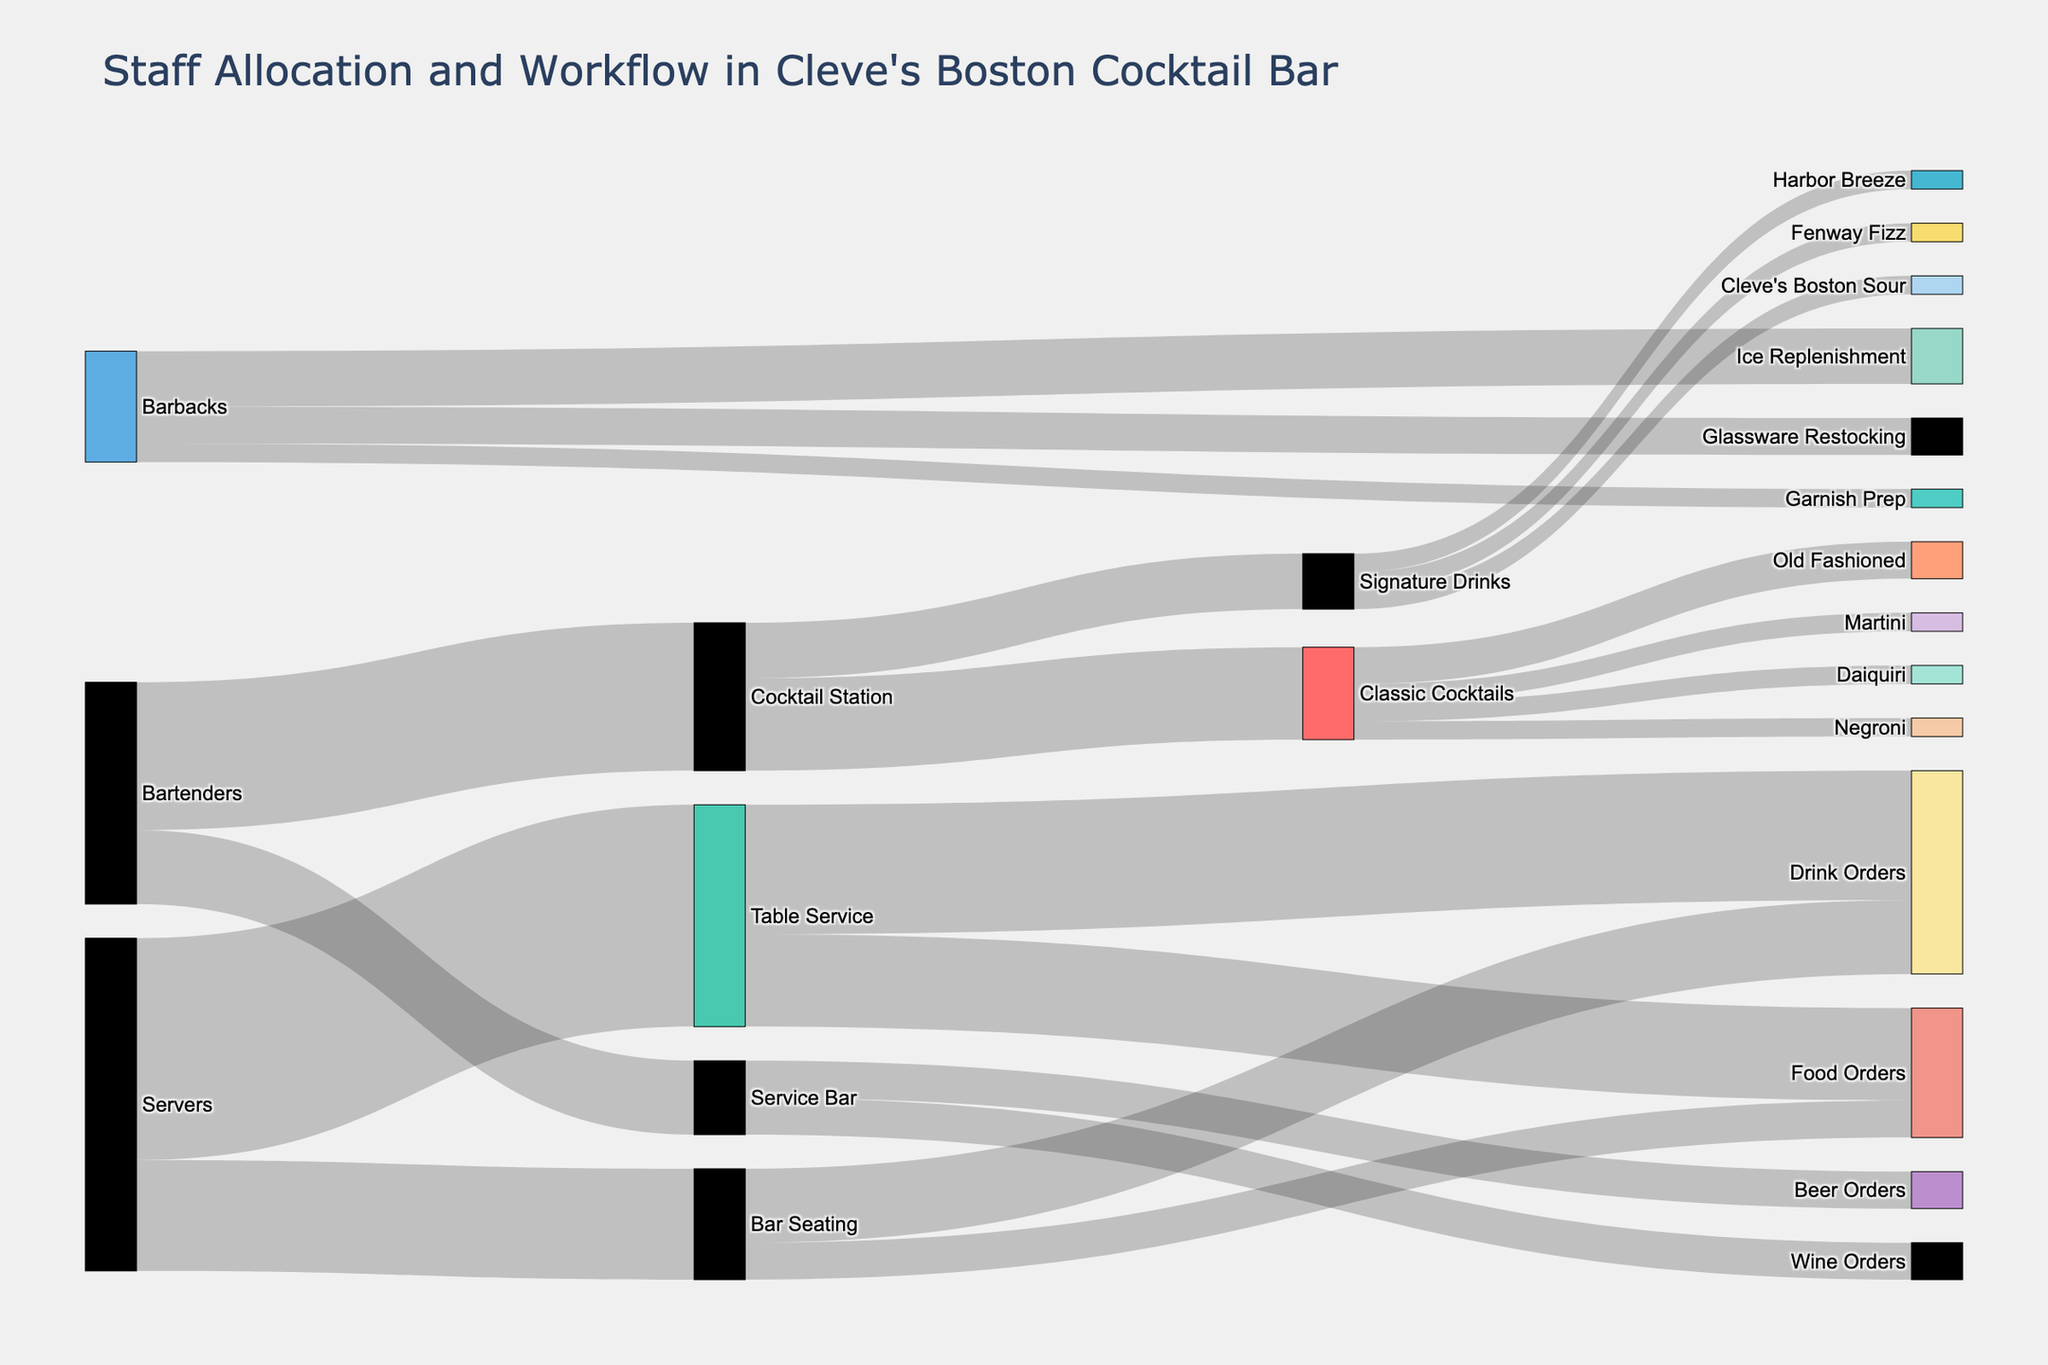What are the total values assigned to the Cocktail Station? Adding the values from Bartenders to Cocktail Station, we get 8. Summing this with the value split into Classic Cocktails (5) and Signature Drinks (3) gives 8. Thus, the total value for the Cocktail Station is just 8.
Answer: 8 Which category has more staff allocated: Servers or Bartenders? From the figure, Servers are allocated 18 (12 for Table Service and 6 for Bar Seating) and Bartenders are allocated 12 (8 for Cocktail Station and 4 for Service Bar). Since 18 is greater than 12, Servers have more staff allocated.
Answer: Servers What’s the most common task handled by the Cocktail Station? The figure shows that the Cocktail Station splits into Classic Cocktails and Signature Drinks, with Classic Cocktails having a higher value of 5 compared to 3 for Signature Drinks. Hence, Classic Cocktails is the most common task.
Answer: Classic Cocktails How many staff members deal with drink-related tasks at Service Bar? From the figure, Service Bar splits its tasks into Beer Orders (2) and Wine Orders (2). Summing these values gives 2 + 2 = 4 staff members handling drink-related tasks.
Answer: 4 Which specific cocktail has the highest value for Classic Cocktails? The Classic Cocktails segment splits into Old Fashioned (2), Martini (1), Negroni (1), and Daiquiri (1). The Old Fashioned has the highest individual value of 2.
Answer: Old Fashioned What's the total value allocated to drink orders from both Table Service and Bar Seating? Table Service has a value of 7 for drink orders, and Bar Seating has 4 for drink orders. Summing them up, we get 7 + 4 = 11.
Answer: 11 Compare the number of staff handling food orders at Table Service versus Bar Seating. From the figure, Table Service has a value of 5 for food orders, whereas Bar Seating has a value of 2. Since 5 is greater than 2, more staff handle food orders at Table Service.
Answer: Table Service What’s the combined value of the unique Signature Drinks listed? Signature Drinks include Cleve's Boston Sour (1), Fenway Fizz (1), and Harbor Breeze (1). Adding these values, we get 1 + 1 + 1 = 3.
Answer: 3 How many staff members does each Barback task need in total? The barback tasks split into Ice Replenishment (3), Glassware Restocking (2), and Garnish Prep (1). Summing these, we get 3 + 2 + 1 = 6.
Answer: 6 